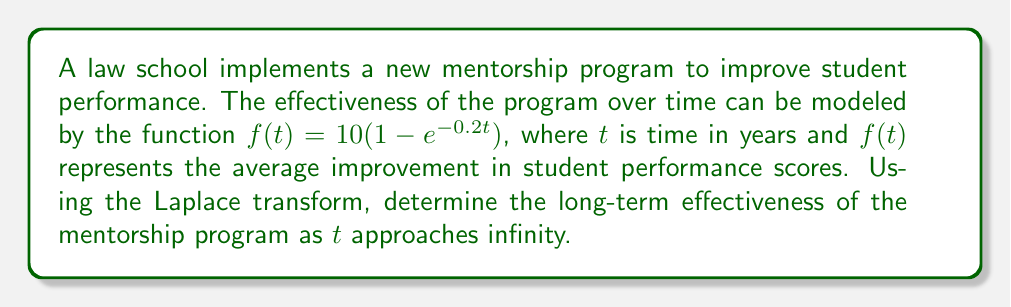Can you solve this math problem? To solve this problem, we'll use the Laplace transform and its final value theorem. Let's break it down step-by-step:

1) First, let's recall the Laplace transform of the function $f(t) = 1 - e^{-at}$:

   $\mathcal{L}\{1 - e^{-at}\} = \frac{1}{s} - \frac{1}{s+a}$

2) In our case, $f(t) = 10(1 - e^{-0.2t})$, so $a = 0.2$ and we have a factor of 10:

   $F(s) = \mathcal{L}\{f(t)\} = 10(\frac{1}{s} - \frac{1}{s+0.2})$

3) To find the long-term effectiveness as $t$ approaches infinity, we can use the final value theorem of Laplace transforms. This theorem states that:

   $\lim_{t \to \infty} f(t) = \lim_{s \to 0} sF(s)$

4) Let's apply this theorem:

   $\lim_{t \to \infty} f(t) = \lim_{s \to 0} s \cdot 10(\frac{1}{s} - \frac{1}{s+0.2})$

5) Simplify:
   
   $= \lim_{s \to 0} 10(1 - \frac{s}{s+0.2})$
   
   $= 10(1 - \frac{0}{0+0.2})$
   
   $= 10(1 - 0)$
   
   $= 10$

Therefore, the long-term effectiveness of the mentorship program, as $t$ approaches infinity, is an average improvement of 10 points in student performance scores.
Answer: 10 